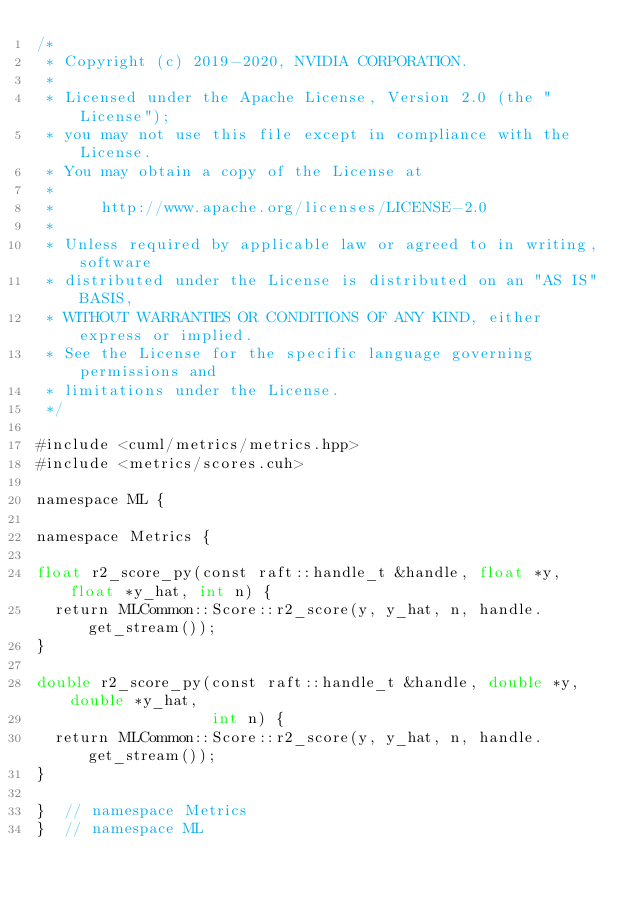Convert code to text. <code><loc_0><loc_0><loc_500><loc_500><_Cuda_>/*
 * Copyright (c) 2019-2020, NVIDIA CORPORATION.
 *
 * Licensed under the Apache License, Version 2.0 (the "License");
 * you may not use this file except in compliance with the License.
 * You may obtain a copy of the License at
 *
 *     http://www.apache.org/licenses/LICENSE-2.0
 *
 * Unless required by applicable law or agreed to in writing, software
 * distributed under the License is distributed on an "AS IS" BASIS,
 * WITHOUT WARRANTIES OR CONDITIONS OF ANY KIND, either express or implied.
 * See the License for the specific language governing permissions and
 * limitations under the License.
 */

#include <cuml/metrics/metrics.hpp>
#include <metrics/scores.cuh>

namespace ML {

namespace Metrics {

float r2_score_py(const raft::handle_t &handle, float *y, float *y_hat, int n) {
  return MLCommon::Score::r2_score(y, y_hat, n, handle.get_stream());
}

double r2_score_py(const raft::handle_t &handle, double *y, double *y_hat,
                   int n) {
  return MLCommon::Score::r2_score(y, y_hat, n, handle.get_stream());
}

}  // namespace Metrics
}  // namespace ML
</code> 